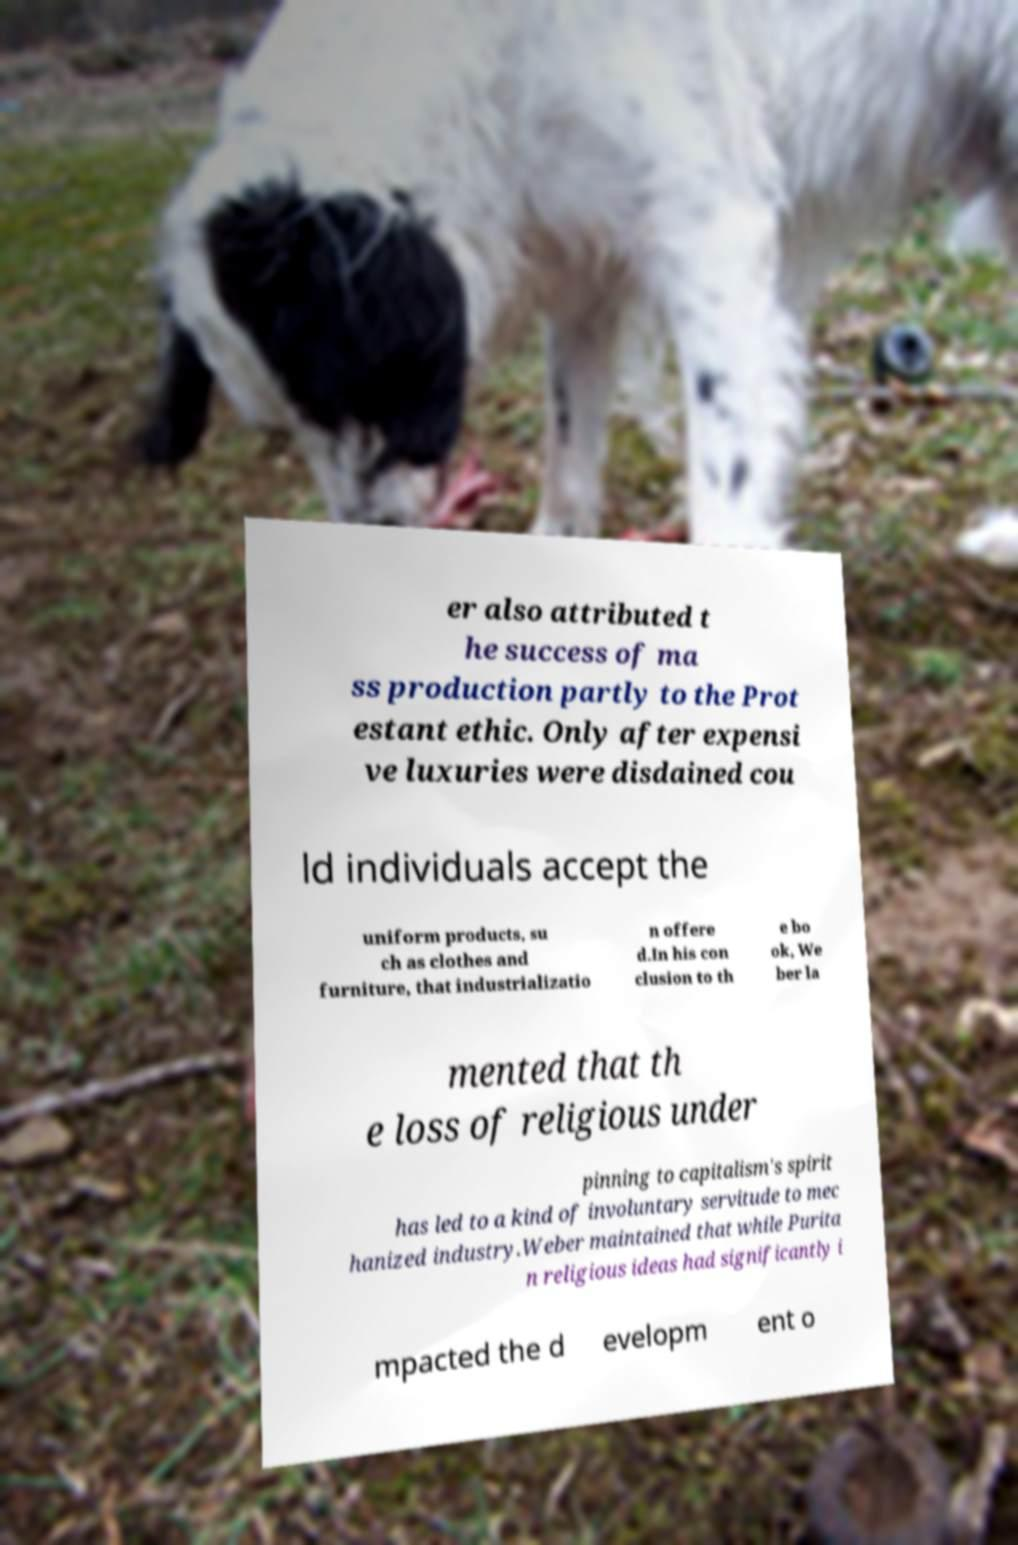Could you assist in decoding the text presented in this image and type it out clearly? er also attributed t he success of ma ss production partly to the Prot estant ethic. Only after expensi ve luxuries were disdained cou ld individuals accept the uniform products, su ch as clothes and furniture, that industrializatio n offere d.In his con clusion to th e bo ok, We ber la mented that th e loss of religious under pinning to capitalism's spirit has led to a kind of involuntary servitude to mec hanized industry.Weber maintained that while Purita n religious ideas had significantly i mpacted the d evelopm ent o 